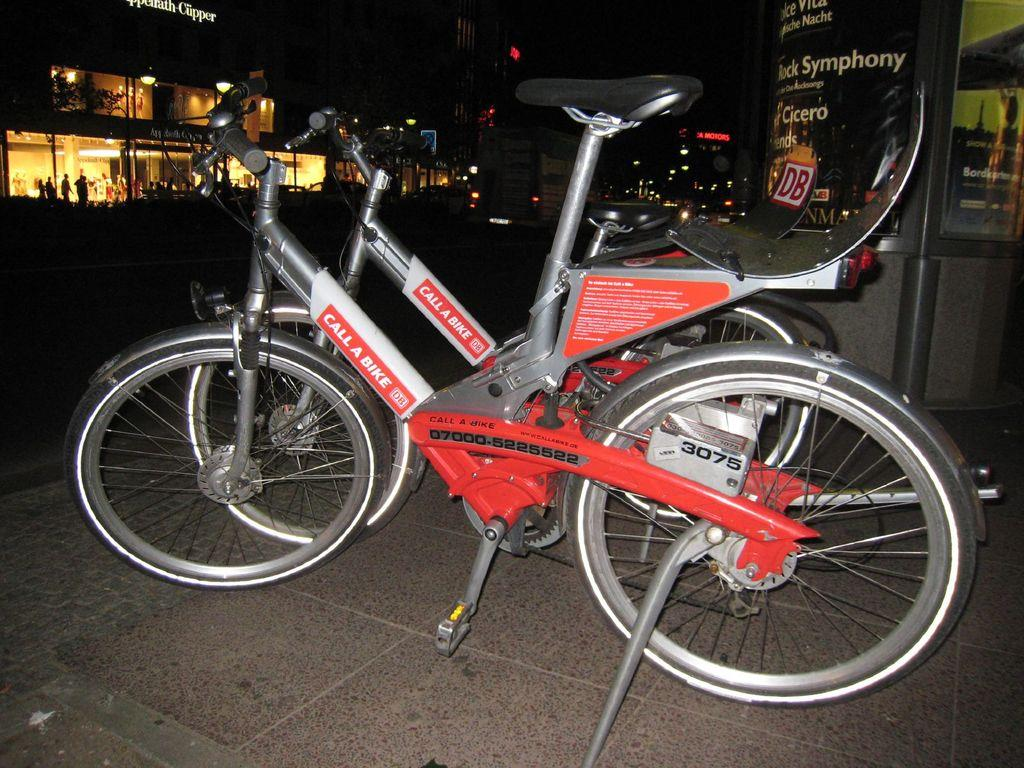What objects are on the floor in the image? There are two bicycles on the floor. What can be seen in the background of the image? There are lights, buildings, and people visible in the background. How would you describe the lighting in the background? The background appears to be dark. Can you see a maid cleaning the cave near the seashore in the image? There is no cave, seashore, or maid present in the image. 